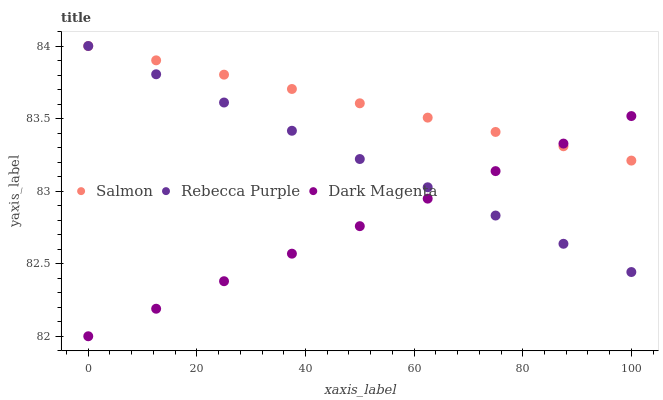Does Dark Magenta have the minimum area under the curve?
Answer yes or no. Yes. Does Salmon have the maximum area under the curve?
Answer yes or no. Yes. Does Rebecca Purple have the minimum area under the curve?
Answer yes or no. No. Does Rebecca Purple have the maximum area under the curve?
Answer yes or no. No. Is Salmon the smoothest?
Answer yes or no. Yes. Is Rebecca Purple the roughest?
Answer yes or no. Yes. Is Rebecca Purple the smoothest?
Answer yes or no. No. Is Dark Magenta the roughest?
Answer yes or no. No. Does Dark Magenta have the lowest value?
Answer yes or no. Yes. Does Rebecca Purple have the lowest value?
Answer yes or no. No. Does Rebecca Purple have the highest value?
Answer yes or no. Yes. Does Dark Magenta have the highest value?
Answer yes or no. No. Does Salmon intersect Rebecca Purple?
Answer yes or no. Yes. Is Salmon less than Rebecca Purple?
Answer yes or no. No. Is Salmon greater than Rebecca Purple?
Answer yes or no. No. 